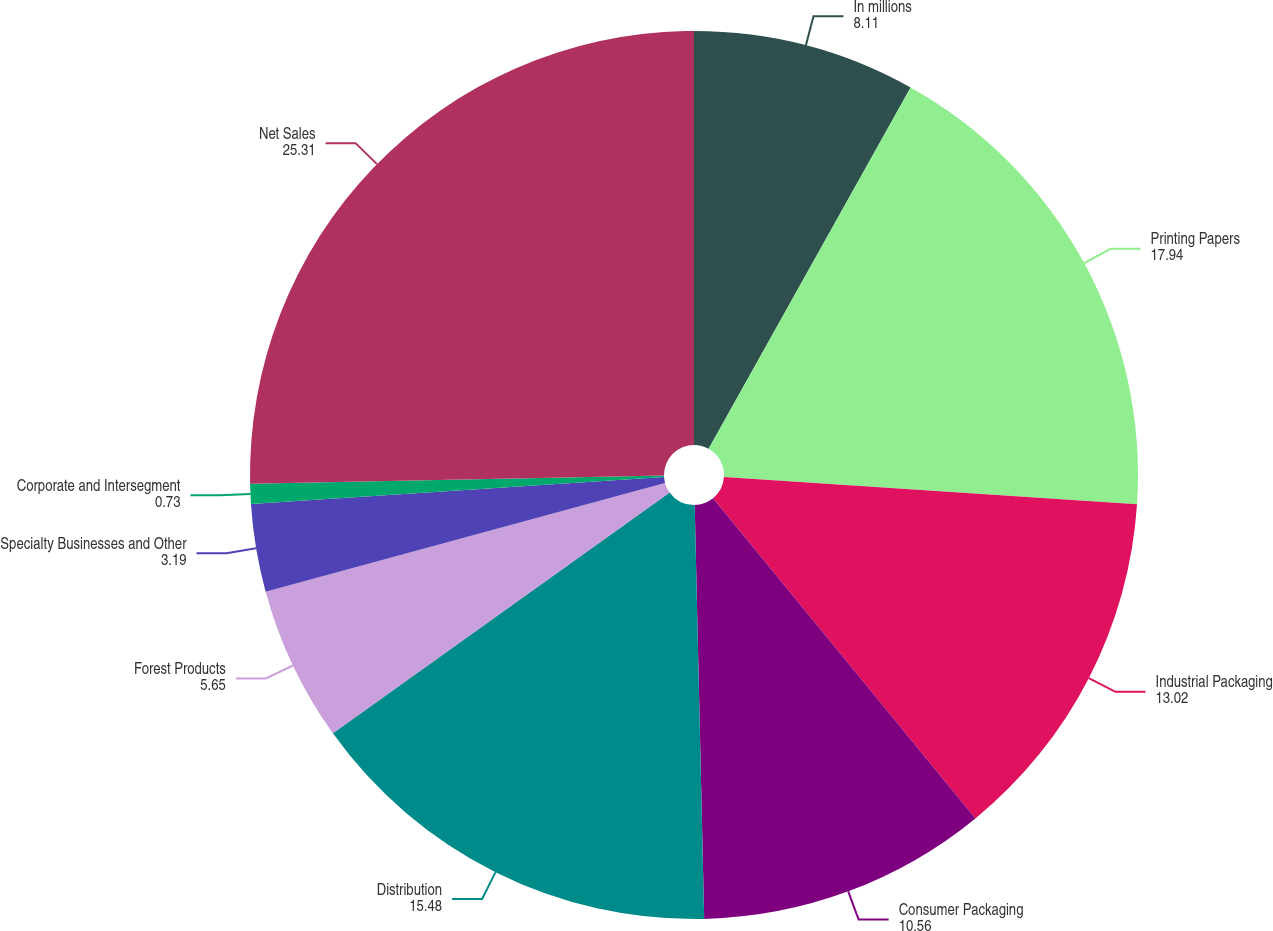Convert chart. <chart><loc_0><loc_0><loc_500><loc_500><pie_chart><fcel>In millions<fcel>Printing Papers<fcel>Industrial Packaging<fcel>Consumer Packaging<fcel>Distribution<fcel>Forest Products<fcel>Specialty Businesses and Other<fcel>Corporate and Intersegment<fcel>Net Sales<nl><fcel>8.11%<fcel>17.94%<fcel>13.02%<fcel>10.56%<fcel>15.48%<fcel>5.65%<fcel>3.19%<fcel>0.73%<fcel>25.31%<nl></chart> 